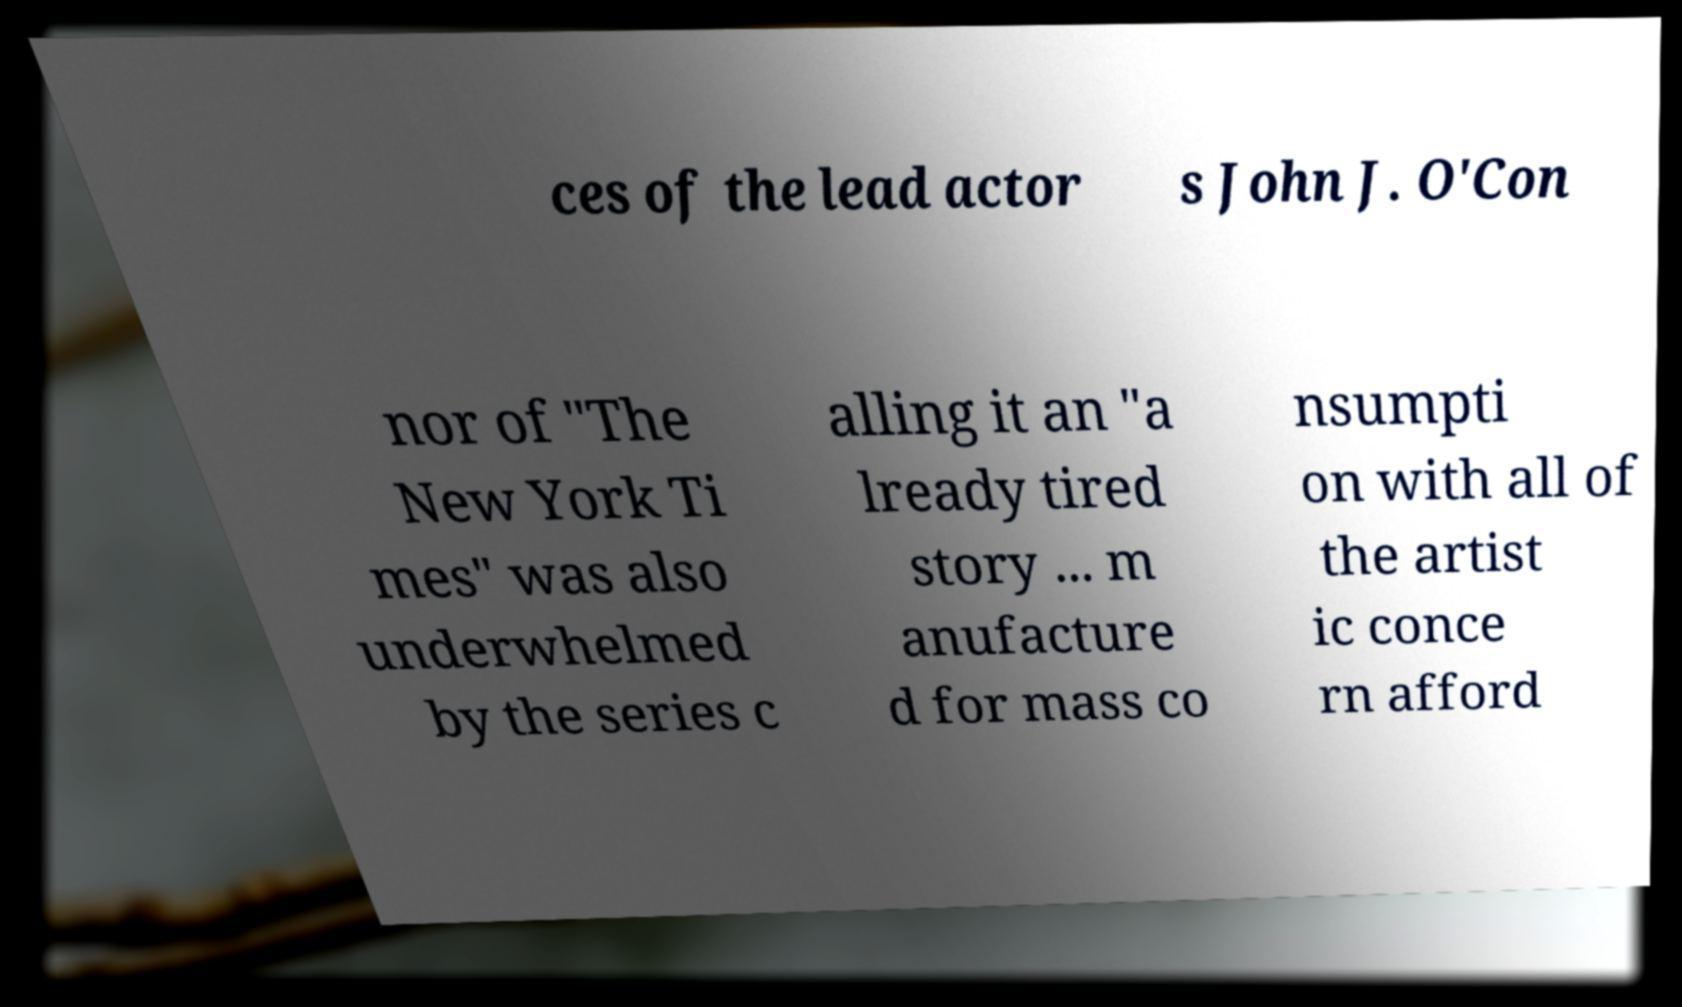What messages or text are displayed in this image? I need them in a readable, typed format. ces of the lead actor s John J. O'Con nor of "The New York Ti mes" was also underwhelmed by the series c alling it an "a lready tired story ... m anufacture d for mass co nsumpti on with all of the artist ic conce rn afford 